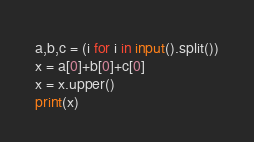<code> <loc_0><loc_0><loc_500><loc_500><_Python_>a,b,c = (i for i in input().split())
x = a[0]+b[0]+c[0]
x = x.upper()
print(x)</code> 